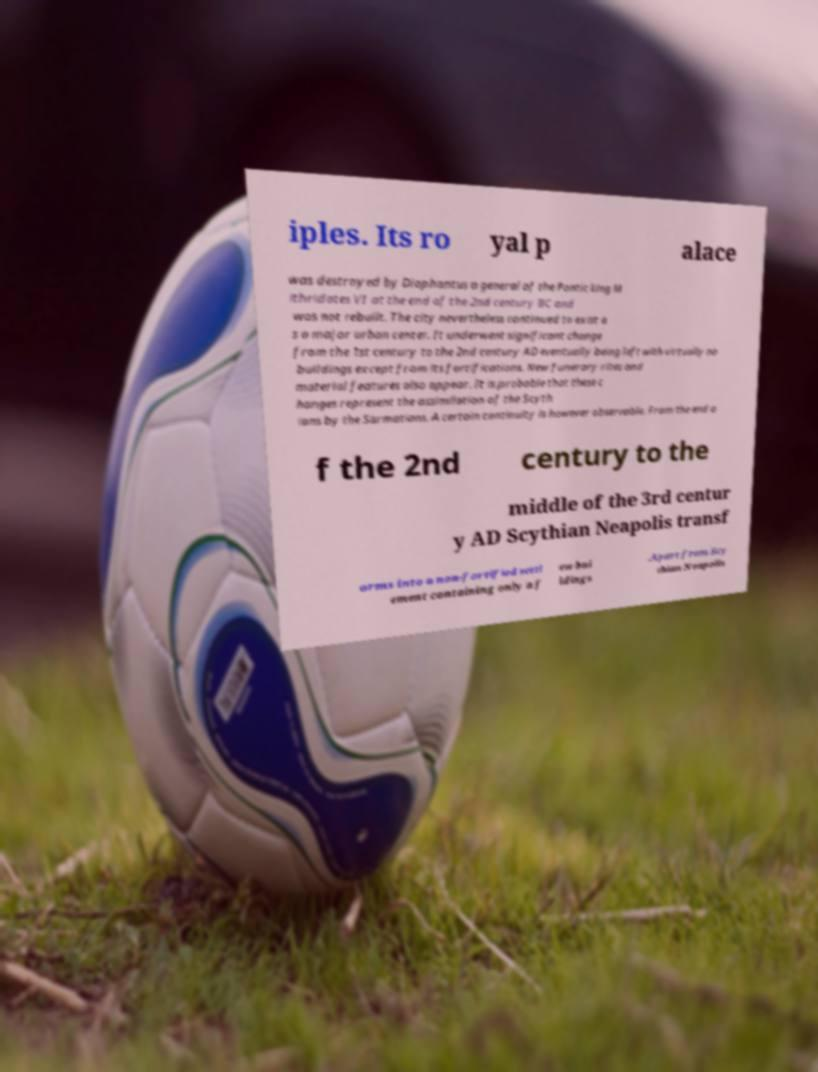What messages or text are displayed in this image? I need them in a readable, typed format. iples. Its ro yal p alace was destroyed by Diophantus a general of the Pontic king M ithridates VI at the end of the 2nd century BC and was not rebuilt. The city nevertheless continued to exist a s a major urban center. It underwent significant change from the 1st century to the 2nd century AD eventually being left with virtually no buildings except from its fortifications. New funerary rites and material features also appear. It is probable that these c hanges represent the assimilation of the Scyth ians by the Sarmatians. A certain continuity is however observable. From the end o f the 2nd century to the middle of the 3rd centur y AD Scythian Neapolis transf orms into a non-fortified settl ement containing only a f ew bui ldings .Apart from Scy thian Neapolis 